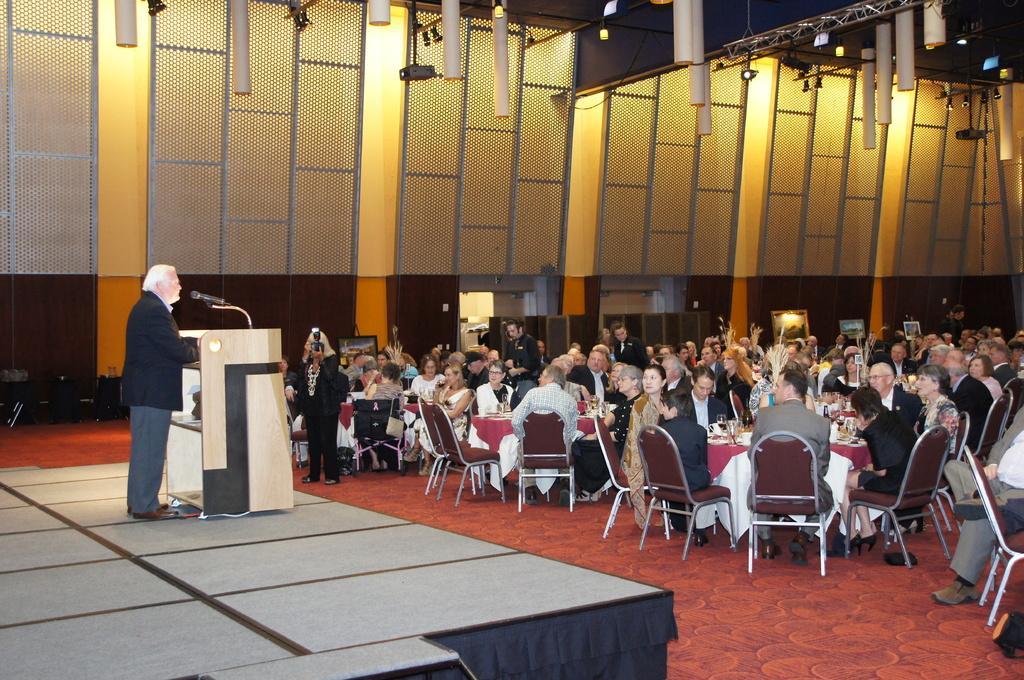How would you summarize this image in a sentence or two? In this picture there are group of people sitting on the chair. There is a man standing. There is a podium and a mic. There is a carpet and files at the background. There are bags. 